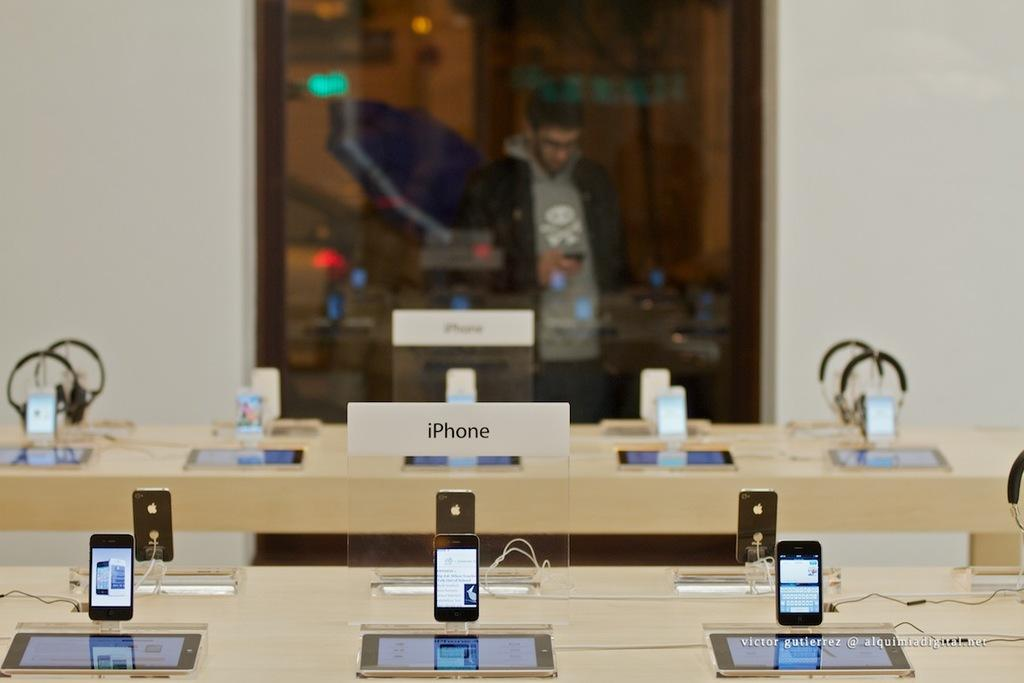<image>
Provide a brief description of the given image. display of several iphones against a mirror with a guy using a phone in the reflection 